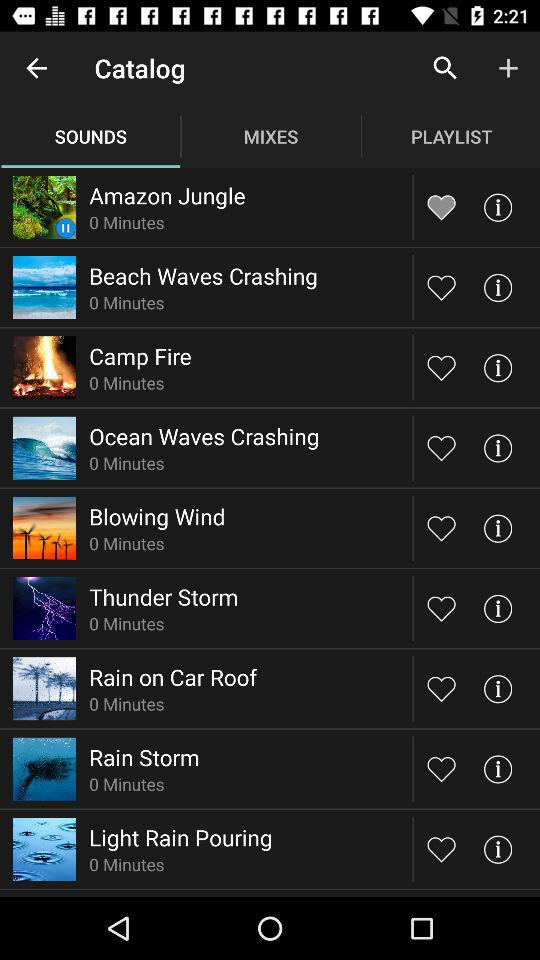Which tab has been selected? The tab that has been selected is "SOUNDS". 